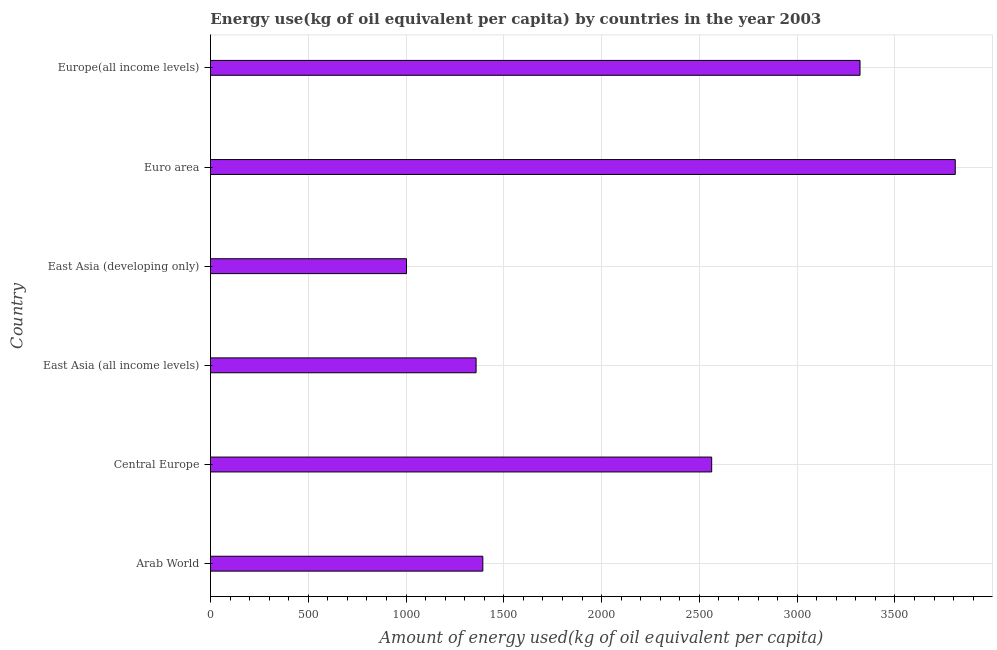Does the graph contain any zero values?
Provide a short and direct response. No. Does the graph contain grids?
Provide a succinct answer. Yes. What is the title of the graph?
Keep it short and to the point. Energy use(kg of oil equivalent per capita) by countries in the year 2003. What is the label or title of the X-axis?
Ensure brevity in your answer.  Amount of energy used(kg of oil equivalent per capita). What is the label or title of the Y-axis?
Your response must be concise. Country. What is the amount of energy used in Arab World?
Provide a succinct answer. 1392.61. Across all countries, what is the maximum amount of energy used?
Keep it short and to the point. 3808.19. Across all countries, what is the minimum amount of energy used?
Your answer should be very brief. 1002.38. In which country was the amount of energy used maximum?
Your response must be concise. Euro area. In which country was the amount of energy used minimum?
Your answer should be compact. East Asia (developing only). What is the sum of the amount of energy used?
Provide a succinct answer. 1.34e+04. What is the difference between the amount of energy used in Arab World and Central Europe?
Offer a terse response. -1170.17. What is the average amount of energy used per country?
Make the answer very short. 2240.89. What is the median amount of energy used?
Make the answer very short. 1977.69. In how many countries, is the amount of energy used greater than 3100 kg?
Provide a short and direct response. 2. What is the ratio of the amount of energy used in East Asia (all income levels) to that in Europe(all income levels)?
Ensure brevity in your answer.  0.41. Is the amount of energy used in Central Europe less than that in East Asia (all income levels)?
Offer a very short reply. No. Is the difference between the amount of energy used in Arab World and East Asia (all income levels) greater than the difference between any two countries?
Your answer should be compact. No. What is the difference between the highest and the second highest amount of energy used?
Offer a very short reply. 486.96. What is the difference between the highest and the lowest amount of energy used?
Offer a terse response. 2805.81. In how many countries, is the amount of energy used greater than the average amount of energy used taken over all countries?
Offer a very short reply. 3. How many bars are there?
Give a very brief answer. 6. Are all the bars in the graph horizontal?
Your answer should be compact. Yes. How many countries are there in the graph?
Provide a succinct answer. 6. Are the values on the major ticks of X-axis written in scientific E-notation?
Offer a terse response. No. What is the Amount of energy used(kg of oil equivalent per capita) of Arab World?
Your answer should be very brief. 1392.61. What is the Amount of energy used(kg of oil equivalent per capita) of Central Europe?
Give a very brief answer. 2562.78. What is the Amount of energy used(kg of oil equivalent per capita) in East Asia (all income levels)?
Keep it short and to the point. 1358.19. What is the Amount of energy used(kg of oil equivalent per capita) in East Asia (developing only)?
Offer a very short reply. 1002.38. What is the Amount of energy used(kg of oil equivalent per capita) of Euro area?
Give a very brief answer. 3808.19. What is the Amount of energy used(kg of oil equivalent per capita) of Europe(all income levels)?
Your answer should be very brief. 3321.23. What is the difference between the Amount of energy used(kg of oil equivalent per capita) in Arab World and Central Europe?
Offer a terse response. -1170.17. What is the difference between the Amount of energy used(kg of oil equivalent per capita) in Arab World and East Asia (all income levels)?
Provide a short and direct response. 34.42. What is the difference between the Amount of energy used(kg of oil equivalent per capita) in Arab World and East Asia (developing only)?
Make the answer very short. 390.23. What is the difference between the Amount of energy used(kg of oil equivalent per capita) in Arab World and Euro area?
Keep it short and to the point. -2415.58. What is the difference between the Amount of energy used(kg of oil equivalent per capita) in Arab World and Europe(all income levels)?
Provide a short and direct response. -1928.62. What is the difference between the Amount of energy used(kg of oil equivalent per capita) in Central Europe and East Asia (all income levels)?
Give a very brief answer. 1204.59. What is the difference between the Amount of energy used(kg of oil equivalent per capita) in Central Europe and East Asia (developing only)?
Make the answer very short. 1560.4. What is the difference between the Amount of energy used(kg of oil equivalent per capita) in Central Europe and Euro area?
Ensure brevity in your answer.  -1245.41. What is the difference between the Amount of energy used(kg of oil equivalent per capita) in Central Europe and Europe(all income levels)?
Provide a succinct answer. -758.44. What is the difference between the Amount of energy used(kg of oil equivalent per capita) in East Asia (all income levels) and East Asia (developing only)?
Your response must be concise. 355.81. What is the difference between the Amount of energy used(kg of oil equivalent per capita) in East Asia (all income levels) and Euro area?
Keep it short and to the point. -2450. What is the difference between the Amount of energy used(kg of oil equivalent per capita) in East Asia (all income levels) and Europe(all income levels)?
Provide a short and direct response. -1963.04. What is the difference between the Amount of energy used(kg of oil equivalent per capita) in East Asia (developing only) and Euro area?
Your response must be concise. -2805.81. What is the difference between the Amount of energy used(kg of oil equivalent per capita) in East Asia (developing only) and Europe(all income levels)?
Offer a very short reply. -2318.85. What is the difference between the Amount of energy used(kg of oil equivalent per capita) in Euro area and Europe(all income levels)?
Make the answer very short. 486.96. What is the ratio of the Amount of energy used(kg of oil equivalent per capita) in Arab World to that in Central Europe?
Your answer should be very brief. 0.54. What is the ratio of the Amount of energy used(kg of oil equivalent per capita) in Arab World to that in East Asia (all income levels)?
Your answer should be compact. 1.02. What is the ratio of the Amount of energy used(kg of oil equivalent per capita) in Arab World to that in East Asia (developing only)?
Your answer should be very brief. 1.39. What is the ratio of the Amount of energy used(kg of oil equivalent per capita) in Arab World to that in Euro area?
Provide a short and direct response. 0.37. What is the ratio of the Amount of energy used(kg of oil equivalent per capita) in Arab World to that in Europe(all income levels)?
Keep it short and to the point. 0.42. What is the ratio of the Amount of energy used(kg of oil equivalent per capita) in Central Europe to that in East Asia (all income levels)?
Give a very brief answer. 1.89. What is the ratio of the Amount of energy used(kg of oil equivalent per capita) in Central Europe to that in East Asia (developing only)?
Provide a succinct answer. 2.56. What is the ratio of the Amount of energy used(kg of oil equivalent per capita) in Central Europe to that in Euro area?
Your answer should be compact. 0.67. What is the ratio of the Amount of energy used(kg of oil equivalent per capita) in Central Europe to that in Europe(all income levels)?
Your answer should be very brief. 0.77. What is the ratio of the Amount of energy used(kg of oil equivalent per capita) in East Asia (all income levels) to that in East Asia (developing only)?
Ensure brevity in your answer.  1.35. What is the ratio of the Amount of energy used(kg of oil equivalent per capita) in East Asia (all income levels) to that in Euro area?
Ensure brevity in your answer.  0.36. What is the ratio of the Amount of energy used(kg of oil equivalent per capita) in East Asia (all income levels) to that in Europe(all income levels)?
Provide a succinct answer. 0.41. What is the ratio of the Amount of energy used(kg of oil equivalent per capita) in East Asia (developing only) to that in Euro area?
Ensure brevity in your answer.  0.26. What is the ratio of the Amount of energy used(kg of oil equivalent per capita) in East Asia (developing only) to that in Europe(all income levels)?
Provide a succinct answer. 0.3. What is the ratio of the Amount of energy used(kg of oil equivalent per capita) in Euro area to that in Europe(all income levels)?
Keep it short and to the point. 1.15. 